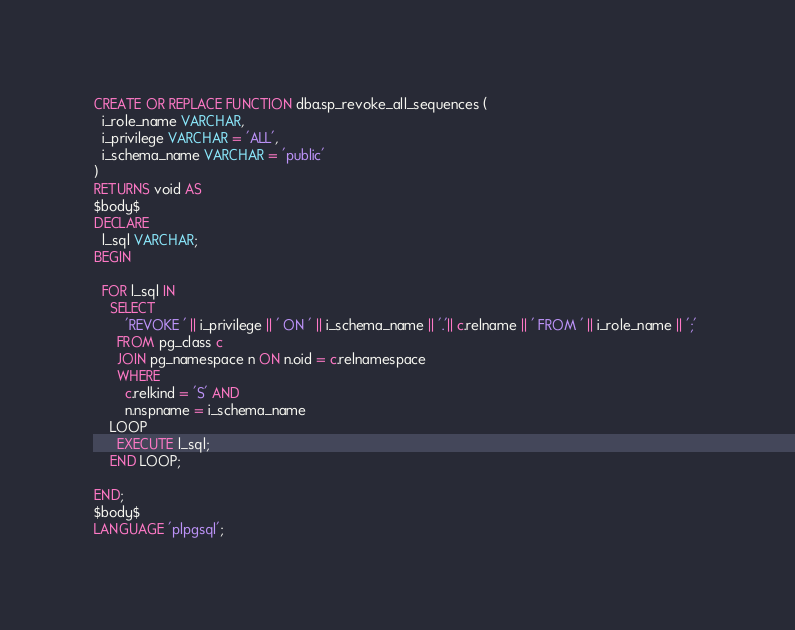<code> <loc_0><loc_0><loc_500><loc_500><_SQL_>CREATE OR REPLACE FUNCTION dba.sp_revoke_all_sequences (
  i_role_name VARCHAR,
  i_privilege VARCHAR = 'ALL',
  i_schema_name VARCHAR = 'public'
)
RETURNS void AS
$body$
DECLARE
  l_sql VARCHAR;
BEGIN
 
  FOR l_sql IN 
    SELECT 
        'REVOKE ' || i_privilege || ' ON ' || i_schema_name || '.'|| c.relname || ' FROM ' || i_role_name || ';' 
      FROM pg_class c 
      JOIN pg_namespace n ON n.oid = c.relnamespace
      WHERE 
        c.relkind = 'S' AND 
        n.nspname = i_schema_name 
    LOOP
      EXECUTE l_sql;
    END LOOP;

END;
$body$
LANGUAGE 'plpgsql';
</code> 